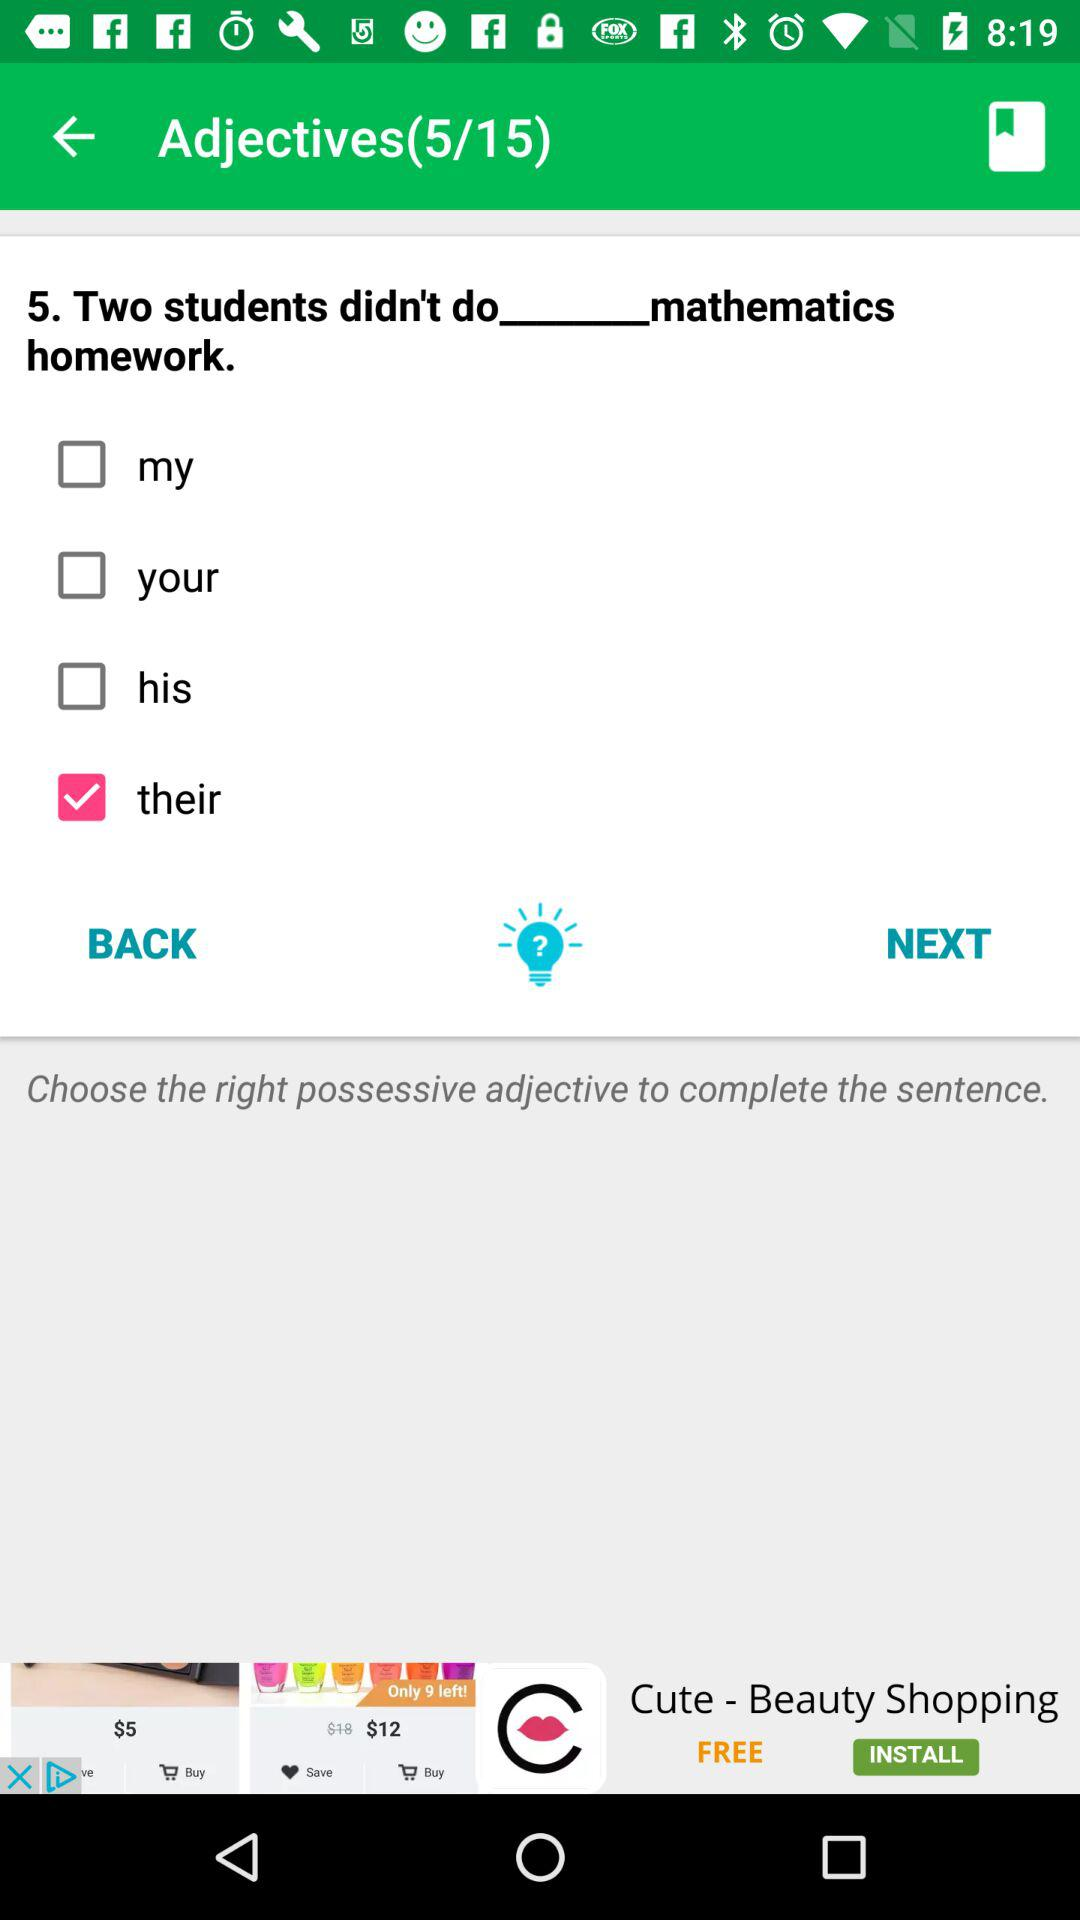How many possessive adjectives are there?
Answer the question using a single word or phrase. 4 